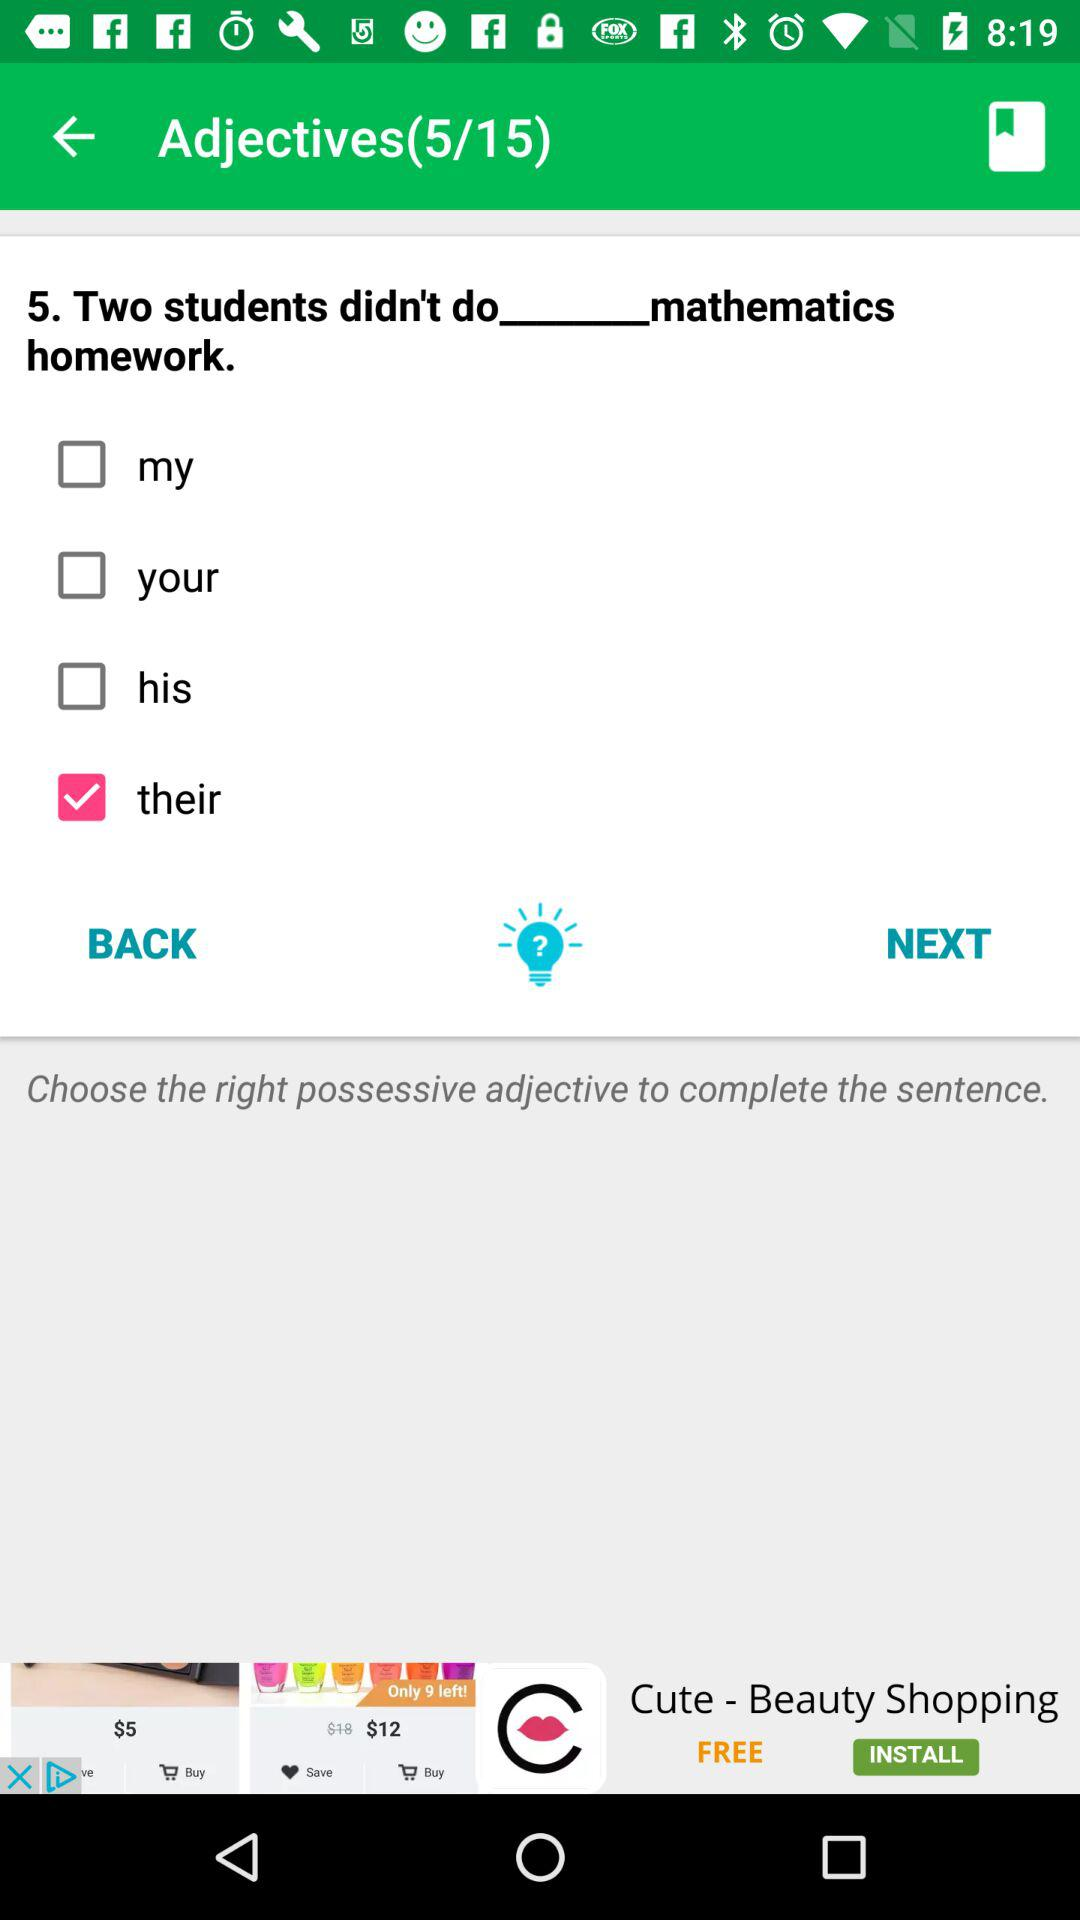How many possessive adjectives are there?
Answer the question using a single word or phrase. 4 